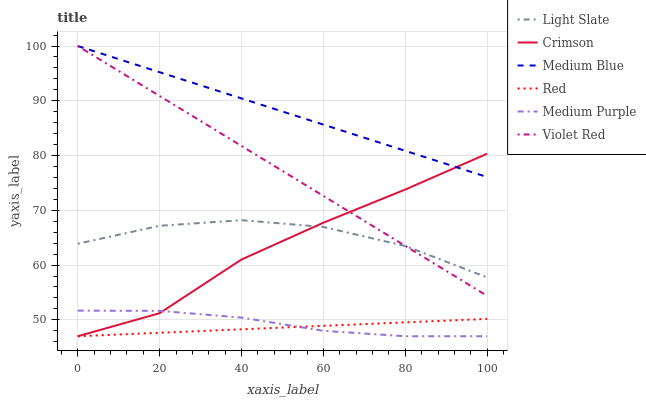Does Red have the minimum area under the curve?
Answer yes or no. Yes. Does Medium Blue have the maximum area under the curve?
Answer yes or no. Yes. Does Light Slate have the minimum area under the curve?
Answer yes or no. No. Does Light Slate have the maximum area under the curve?
Answer yes or no. No. Is Red the smoothest?
Answer yes or no. Yes. Is Crimson the roughest?
Answer yes or no. Yes. Is Light Slate the smoothest?
Answer yes or no. No. Is Light Slate the roughest?
Answer yes or no. No. Does Medium Purple have the lowest value?
Answer yes or no. Yes. Does Light Slate have the lowest value?
Answer yes or no. No. Does Medium Blue have the highest value?
Answer yes or no. Yes. Does Light Slate have the highest value?
Answer yes or no. No. Is Medium Purple less than Medium Blue?
Answer yes or no. Yes. Is Light Slate greater than Red?
Answer yes or no. Yes. Does Medium Blue intersect Crimson?
Answer yes or no. Yes. Is Medium Blue less than Crimson?
Answer yes or no. No. Is Medium Blue greater than Crimson?
Answer yes or no. No. Does Medium Purple intersect Medium Blue?
Answer yes or no. No. 